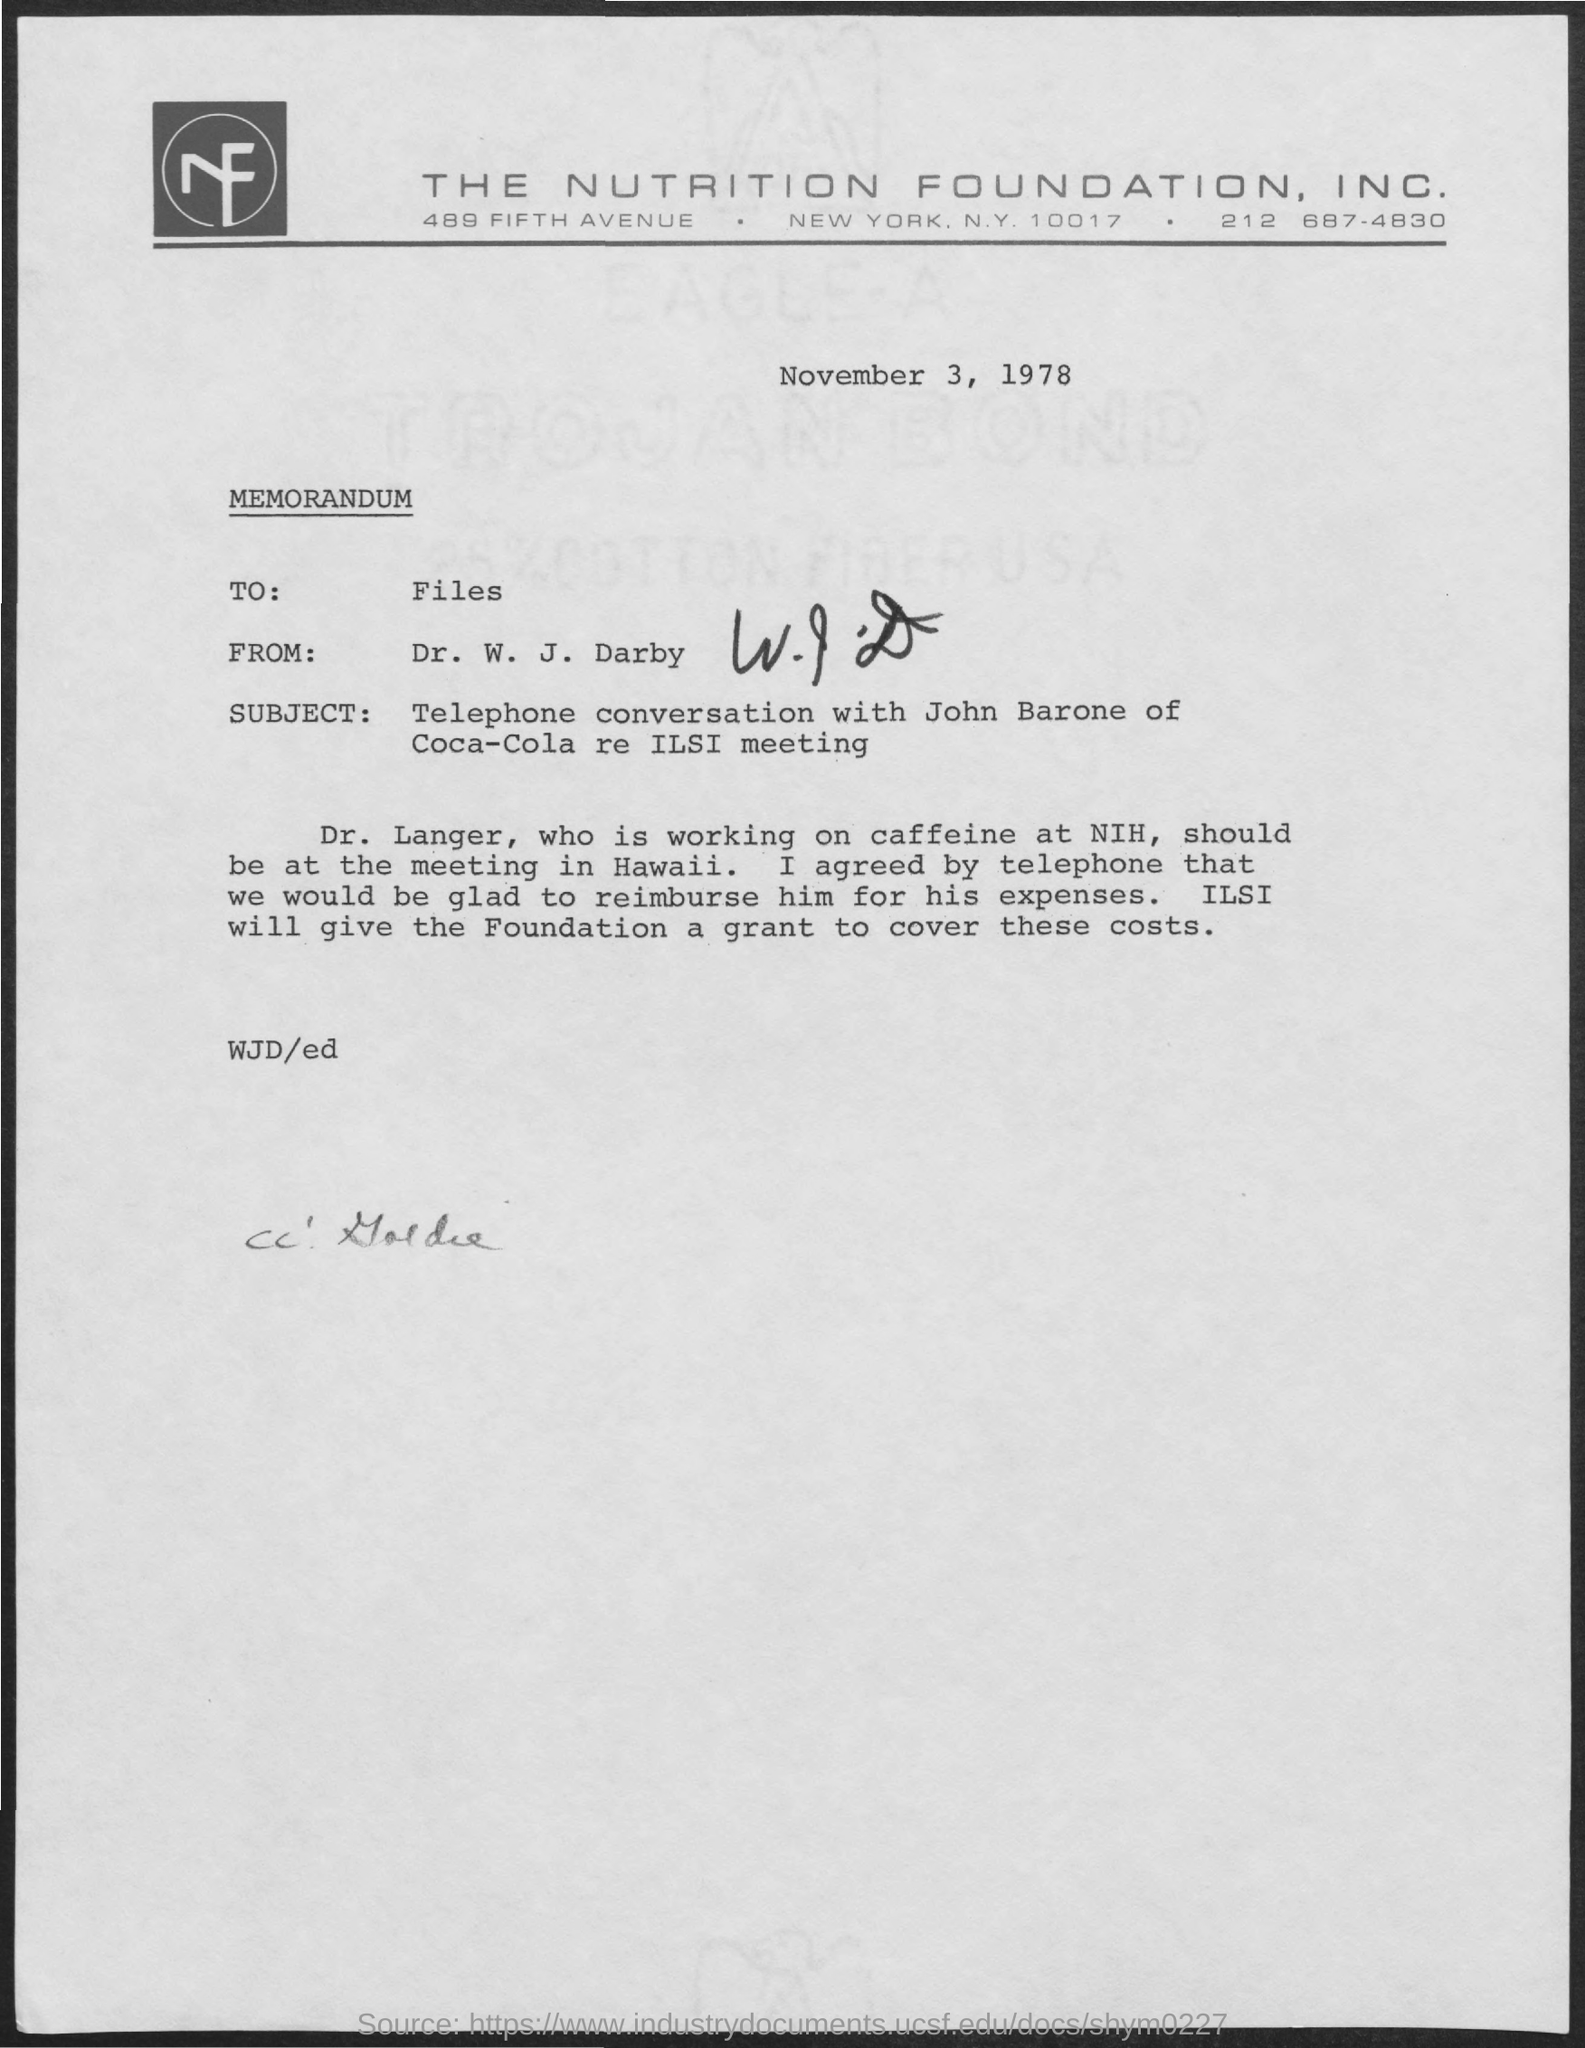What is the date mentioned in the document?
Provide a succinct answer. November 3, 1978. 